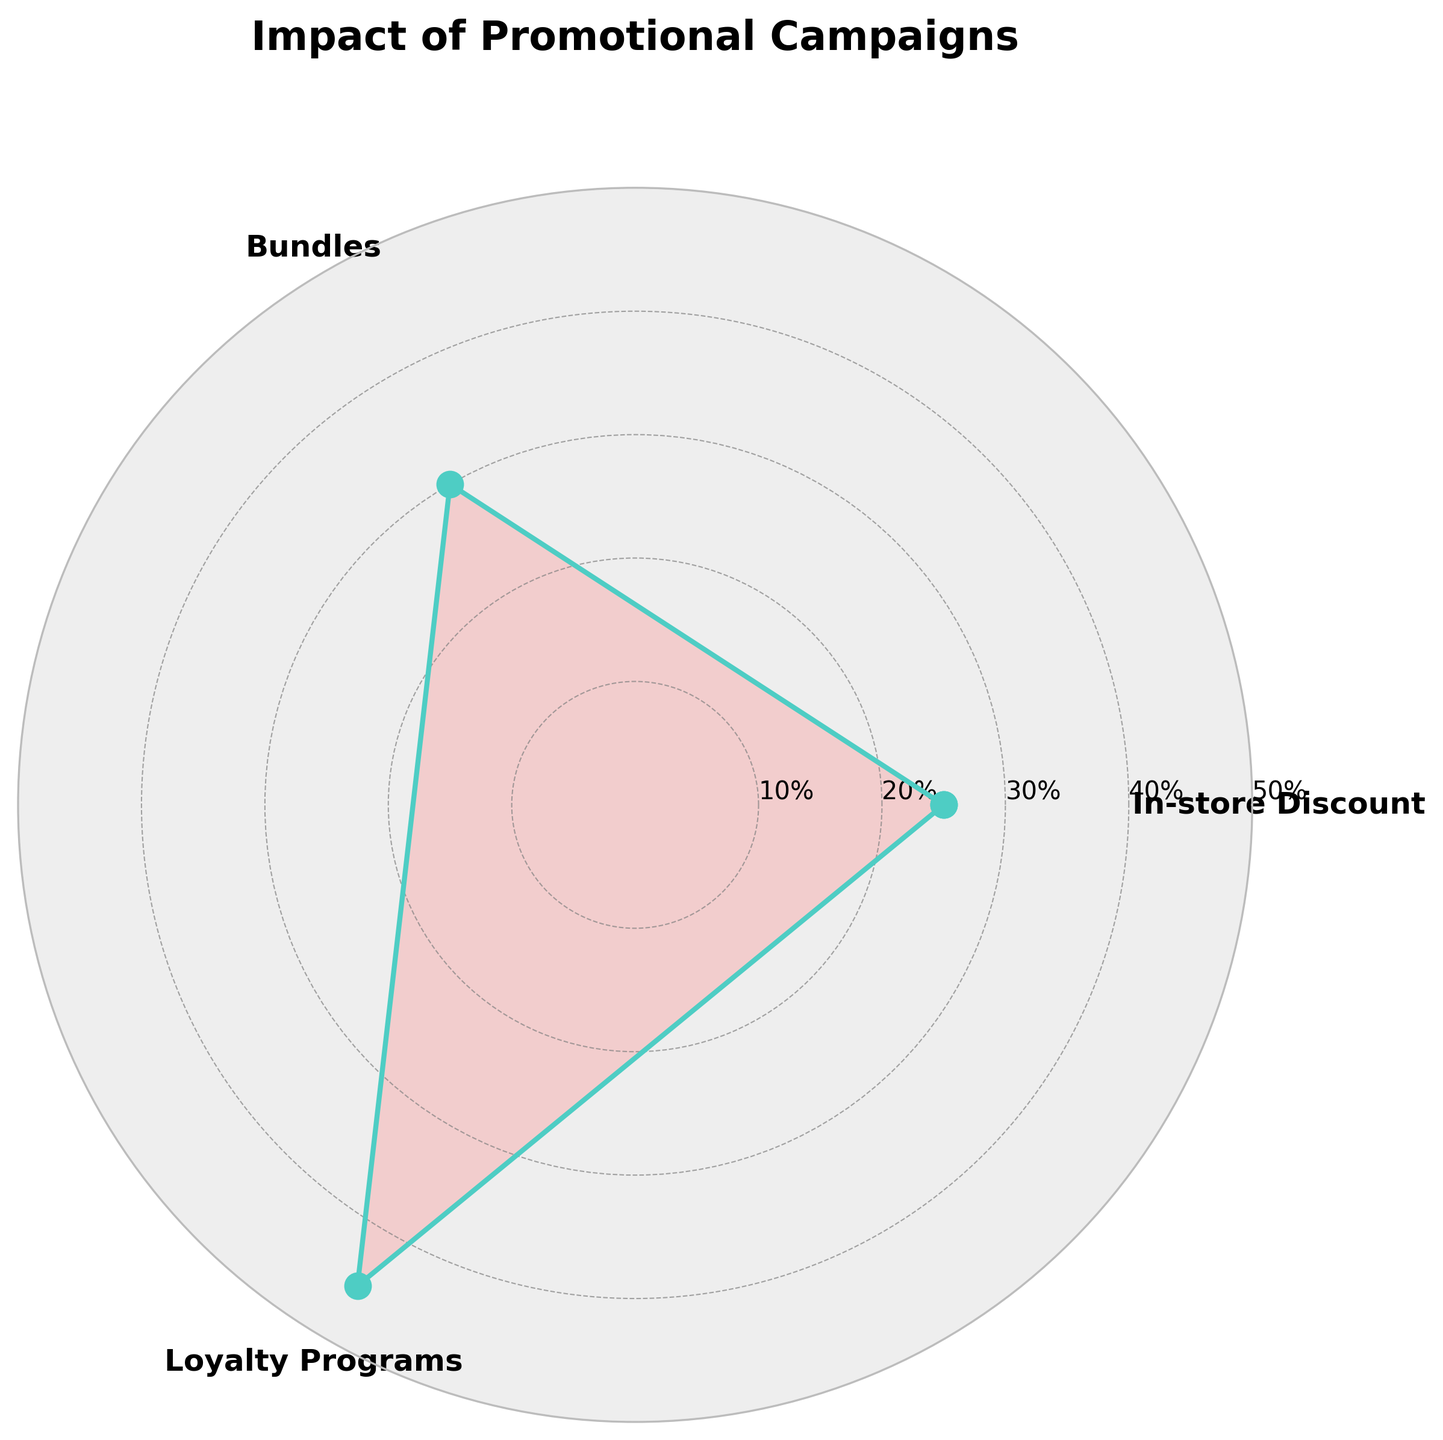What is the title of the rose chart? The title of the rose chart is located at the top of the figure. It provides an overall description of what the chart represents.
Answer: Impact of Promotional Campaigns How many promotional campaigns are displayed in the rose chart? The rose chart shows three sectors, each representing a promotional campaign.
Answer: Three Which promotional campaign has the highest impact percentage? By looking at the longest sector in the chart, you can identify which campaign has the highest value.
Answer: Loyalty Programs What is the difference in impact percentage between the Bundles and In-store Discount campaigns? Bundles have an impact of 30% and In-store Discount has 25%. The difference is calculated as 30% - 25% = 5%.
Answer: 5% What colors are used to represent the data in the rose chart? The rose chart uses a filled area in a light red color and outlines the data with a greenish-blue color.
Answer: Light red and greenish-blue What is the average impact percentage of the promotional campaigns displayed? First sum the impact percentages of all campaigns: 25% + 30% + 45% = 100%. Then, divide by the number of campaigns: 100% / 3 = 33.33%.
Answer: 33.33% Which campaign has the smallest impact percentage? By looking at the shortest sector in the chart, you can identify the campaign with the lowest value.
Answer: In-store Discount By how much does the Loyalty Programs campaign exceed In-store Discount in terms of impact percentage? Loyalty Programs have an impact of 45% and In-store Discount 25%. The difference is 45% - 25% = 20%.
Answer: 20% What is the combined impact percentage of Bundles and In-store Discount? Add the impact percentages of both campaigns: 30% + 25% = 55%.
Answer: 55% Considering the displayed data, what is the most effective promotional campaign? The most effective promotional campaign is the one with the highest impact percentage, which can be identified by its position and length in the chart.
Answer: Loyalty Programs 